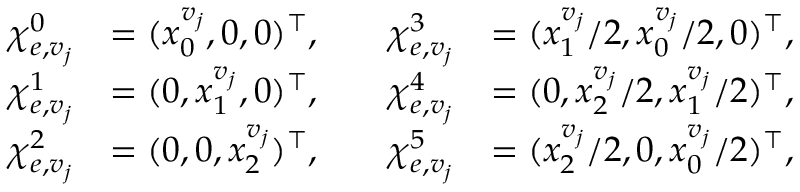Convert formula to latex. <formula><loc_0><loc_0><loc_500><loc_500>\begin{array} { r l r l } { \chi _ { e , v _ { j } } ^ { 0 } } & { = ( x _ { 0 } ^ { v _ { j } } , 0 , 0 ) ^ { \top } , \quad } & { \chi _ { e , v _ { j } } ^ { 3 } } & { = ( x _ { 1 } ^ { v _ { j } } / 2 , x _ { 0 } ^ { v _ { j } } / 2 , 0 ) ^ { \top } , } \\ { \chi _ { e , v _ { j } } ^ { 1 } } & { = ( 0 , x _ { 1 } ^ { v _ { j } } , 0 ) ^ { \top } , \quad } & { \chi _ { e , v _ { j } } ^ { 4 } } & { = ( 0 , x _ { 2 } ^ { v _ { j } } / 2 , x _ { 1 } ^ { v _ { j } } / 2 ) ^ { \top } , } \\ { \chi _ { e , v _ { j } } ^ { 2 } } & { = ( 0 , 0 , x _ { 2 } ^ { v _ { j } } ) ^ { \top } , \quad } & { \chi _ { e , v _ { j } } ^ { 5 } } & { = ( x _ { 2 } ^ { v _ { j } } / 2 , 0 , x _ { 0 } ^ { v _ { j } } / 2 ) ^ { \top } , } \end{array}</formula> 